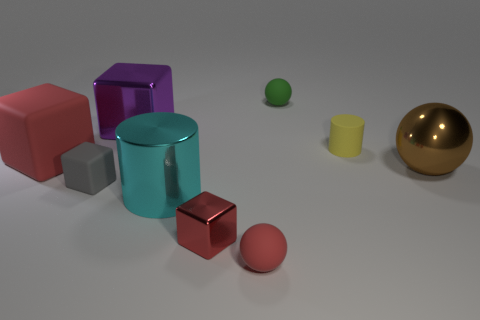Subtract all small balls. How many balls are left? 1 Subtract all red blocks. How many blocks are left? 2 Add 3 shiny blocks. How many shiny blocks are left? 5 Add 8 big brown metallic blocks. How many big brown metallic blocks exist? 8 Subtract 0 gray cylinders. How many objects are left? 9 Subtract all cubes. How many objects are left? 5 Subtract 1 cylinders. How many cylinders are left? 1 Subtract all gray balls. Subtract all cyan cylinders. How many balls are left? 3 Subtract all gray cubes. How many gray cylinders are left? 0 Subtract all big shiny cylinders. Subtract all small cubes. How many objects are left? 6 